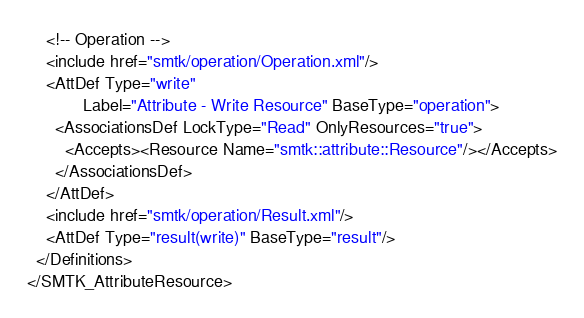Convert code to text. <code><loc_0><loc_0><loc_500><loc_500><_Scala_>    <!-- Operation -->
    <include href="smtk/operation/Operation.xml"/>
    <AttDef Type="write"
            Label="Attribute - Write Resource" BaseType="operation">
      <AssociationsDef LockType="Read" OnlyResources="true">
        <Accepts><Resource Name="smtk::attribute::Resource"/></Accepts>
      </AssociationsDef>
    </AttDef>
    <include href="smtk/operation/Result.xml"/>
    <AttDef Type="result(write)" BaseType="result"/>
  </Definitions>
</SMTK_AttributeResource>
</code> 